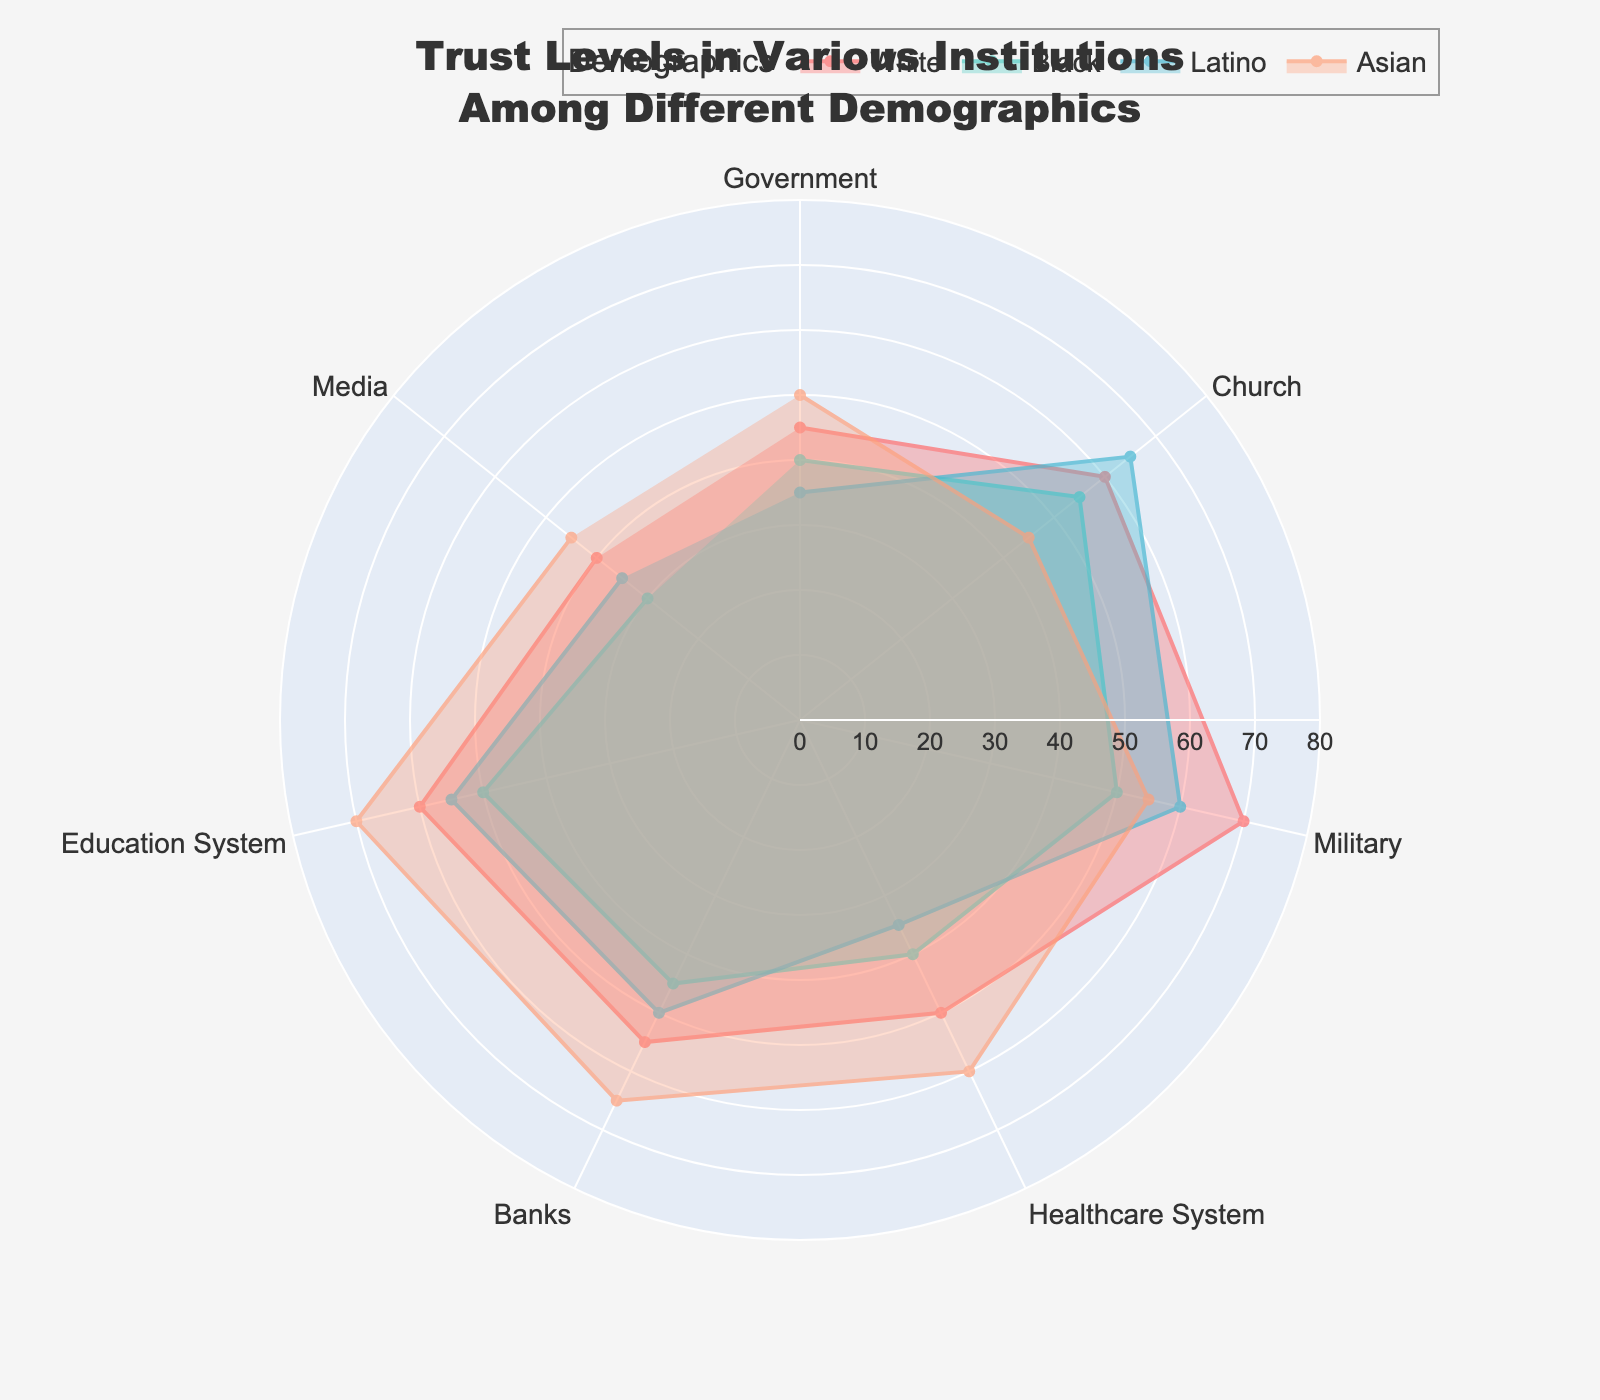What's the title of the plot? The title of the plot is displayed at the top center. It reads: 'Trust Levels in Various Institutions Among Different Demographics'.
Answer: Trust Levels in Various Institutions Among Different Demographics Which demographic group has the highest trust in the Education System? The radial lines corresponding to each demographic group's trust in the Education System extend outward. The label at the outermost point indicates the group. In this case, the 'Asian' group has the highest value with the longest line reaching the value of 70.
Answer: Asian How many institutions are listed in the radar chart? Each institution forms a segment in the radar chart. By counting these segments, we can determine the number of institutions. The plot contains segments for Government, Church, Military, Healthcare System, Banks, Education System, and Media.
Answer: 7 Which institution do Latinos trust the most? Among the institutions, we need to identify the segment where the Latino (blue) line reaches the highest value. In this case, it is the Church, which is at 65.
Answer: Church Compare the trust levels in the Media between White and Black demographics. Locate the segments for Media and check the respective points for White and Black demographics. The White group has a value of 40, whereas the Black group has a value of 30. Therefore, the White demographic has a higher trust level in Media compared to the Black demographic.
Answer: White has higher trust What is the average trust level in the Military across all demographics? Sum the values of trust in the Military for all demographics (White = 70, Black = 50, Latino = 60, Asian = 55) and then divide by the number of demographics (4). (70 + 50 + 60 + 55) / 4 = 58.75
Answer: 58.75 Which demographic group shows the least trust in the Healthcare System? Identify the segment for the Healthcare System and find the shortest lines for each demographic group. The Latino group has the lowest value at 35.
Answer: Latino What is the difference in trust levels in Banks between the Asian and White demographics? Check the values for trust in Banks for both demographics. Asian group is at 65, and White group is at 55. The difference is 65 - 55 = 10.
Answer: 10 What's the median trust level in the Government among all demographics? Organize the trust levels of Government among the demographics in ascending order: 35 (Latino), 40 (Black), 45 (White), 50 (Asian). The median is the average of the two middle numbers: (40 + 45) / 2 = 42.5
Answer: 42.5 Which institution has the widest range of trust levels among the different demographics? Calculate the range for each institution by finding the difference between the highest and lowest trust levels. Government (50-35=15), Church (65-45=20), Military (70-50=20), Healthcare System (60-35=25), Banks (65-45=20), Education System (70-50=20), Media (45-30=15). The widest range is for the Healthcare System with a range of 25.
Answer: Healthcare System 